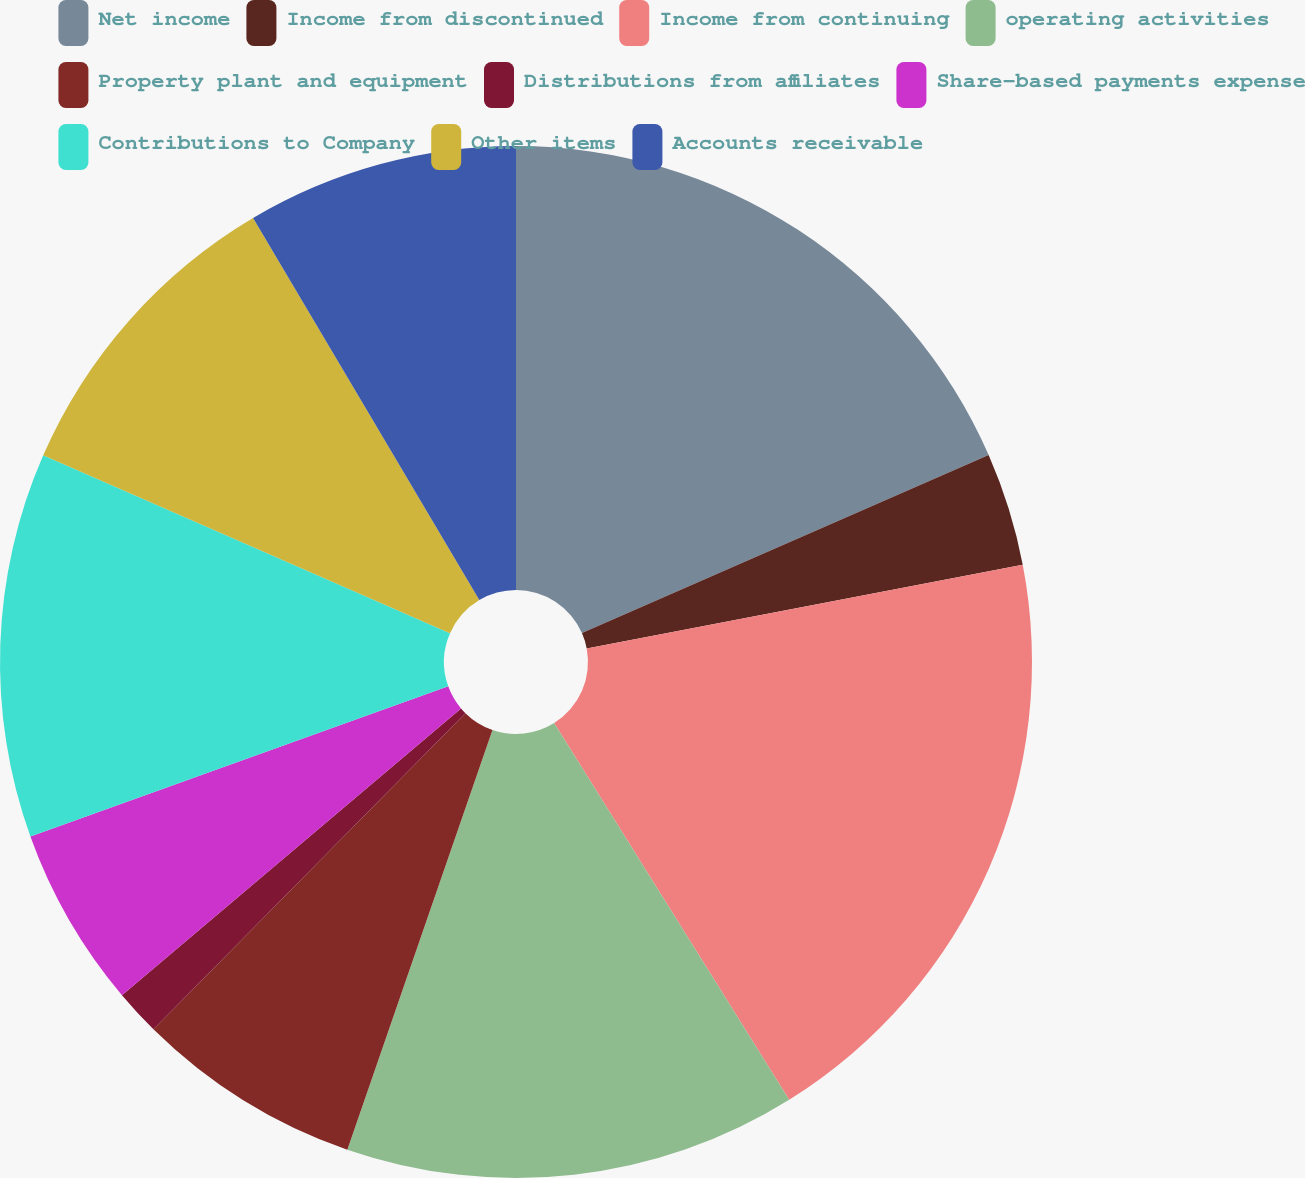<chart> <loc_0><loc_0><loc_500><loc_500><pie_chart><fcel>Net income<fcel>Income from discontinued<fcel>Income from continuing<fcel>operating activities<fcel>Property plant and equipment<fcel>Distributions from affiliates<fcel>Share-based payments expense<fcel>Contributions to Company<fcel>Other items<fcel>Accounts receivable<nl><fcel>18.43%<fcel>3.55%<fcel>19.14%<fcel>14.18%<fcel>7.1%<fcel>1.43%<fcel>5.68%<fcel>12.05%<fcel>9.93%<fcel>8.51%<nl></chart> 